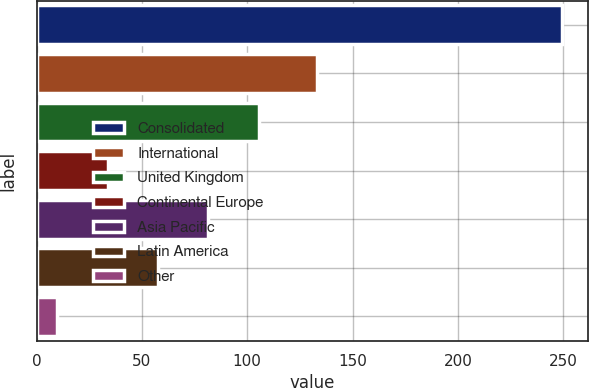Convert chart. <chart><loc_0><loc_0><loc_500><loc_500><bar_chart><fcel>Consolidated<fcel>International<fcel>United Kingdom<fcel>Continental Europe<fcel>Asia Pacific<fcel>Latin America<fcel>Other<nl><fcel>249.4<fcel>133.2<fcel>105.58<fcel>33.67<fcel>81.61<fcel>57.64<fcel>9.7<nl></chart> 